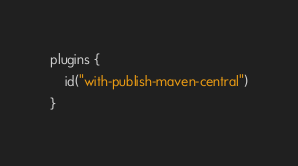Convert code to text. <code><loc_0><loc_0><loc_500><loc_500><_Kotlin_>plugins {
    id("with-publish-maven-central")
}</code> 